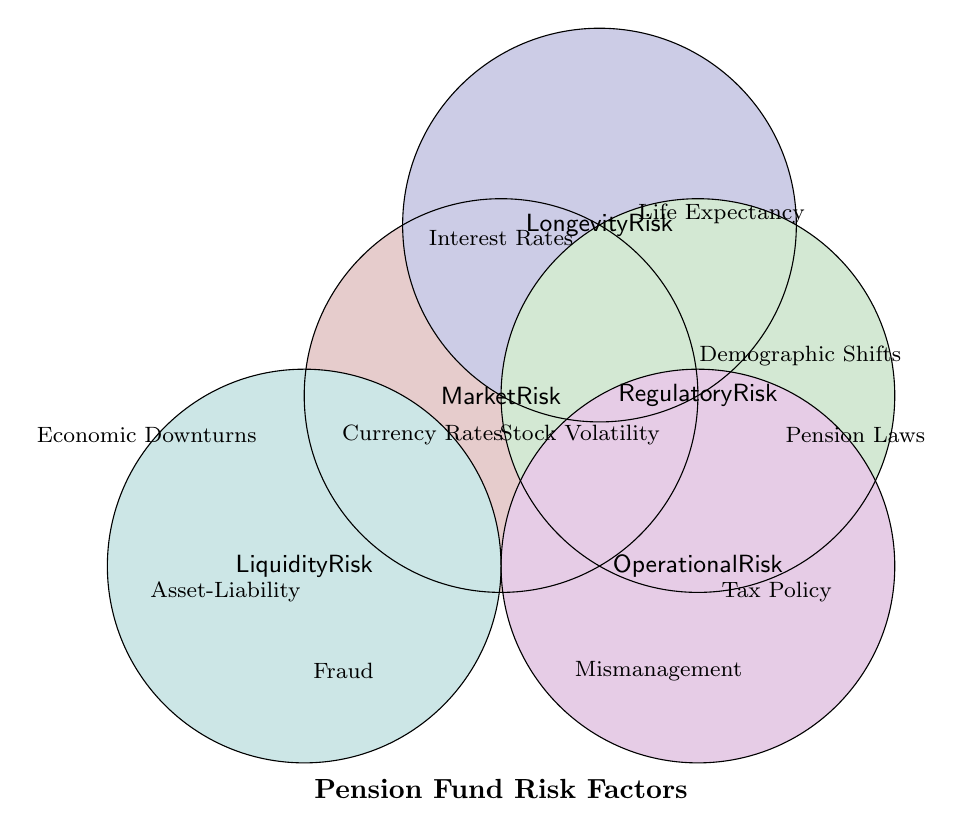What are the risk factors shown for Market Risk? Market Risk has three risk factors shown: Interest Rate Fluctuations, Stock Market Volatility, and Currency Exchange Rates.
Answer: Interest Rate Fluctuations, Stock Market Volatility, Currency Exchange Rates Which risk factor is influenced by Increased Life Expectancy? Increased Life Expectancy affects Longevity Risk, as indicated in the figure.
Answer: Longevity Risk How many risk factors are associated with Operational Risk? According to the figure, Operational Risk is associated with two risk factors: Mismanagement and Fraud.
Answer: Two What is the relationship between Economic Downturns and risk categories? Economic Downturns are associated with Liquidity Risk, as shown in the figure.
Answer: Liquidity Risk If changes in Tax Policy impact a given risk category, which risk category would that be? The figure indicates that Tax Policy Amendments impact Regulatory Risk.
Answer: Regulatory Risk How many unique risk factors are mentioned in the figure? Counting all the unique risk factors mentioned for each category: Interest Rate Fluctuations, Stock Market Volatility, Currency Exchange Rates, Increased Life Expectancy, Demographic Shifts, Changes in Pension Laws, Tax Policy Amendments, Mismanagement, Fraud, Asset-Liability Mismatch, and Economic Downturns, there are 11 unique risk factors.
Answer: 11 Which risk category has the most risk factors associated with it? The figure shows Market Risk has the most risk factors associated with it: three.
Answer: Market Risk Which two risk categories have exactly two risk factors each? The figure shows that Regulatory Risk and Liquidity Risk each have two risk factors associated with them.
Answer: Regulatory Risk, Liquidity Risk 